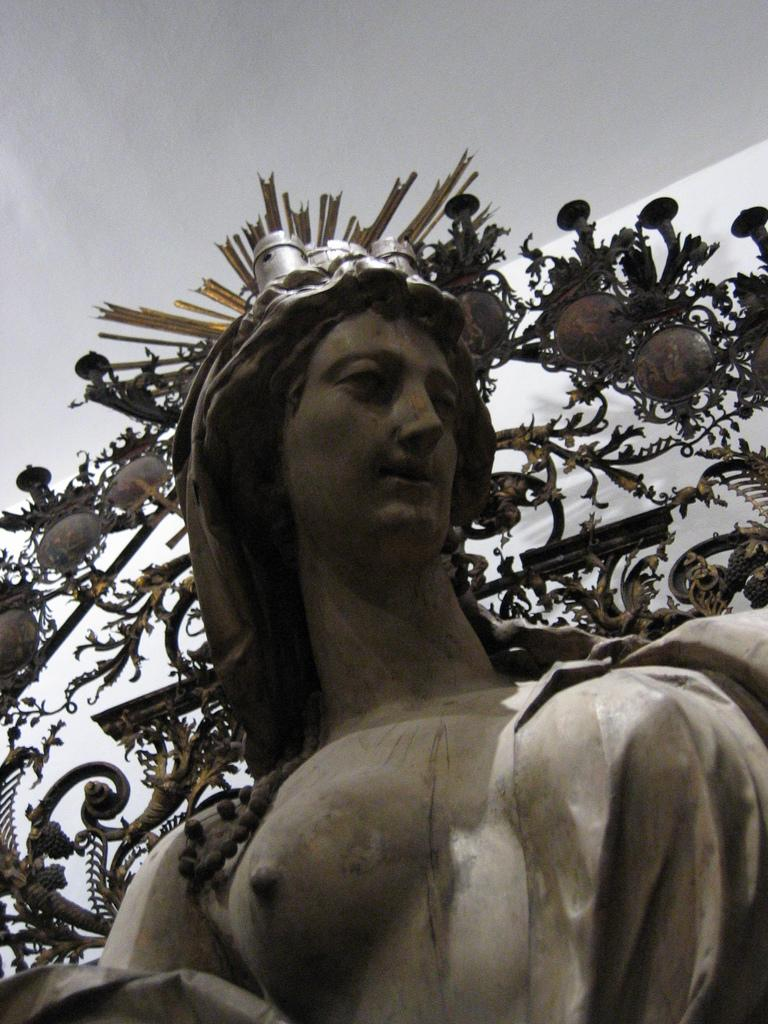What is the main subject in the image? There is a statue in the image. What can be seen in the background of the image? The sky is visible at the top of the image. Can you describe the woman holding an apple in the image? There is no woman holding an apple in the image; it features a statue and the sky. 